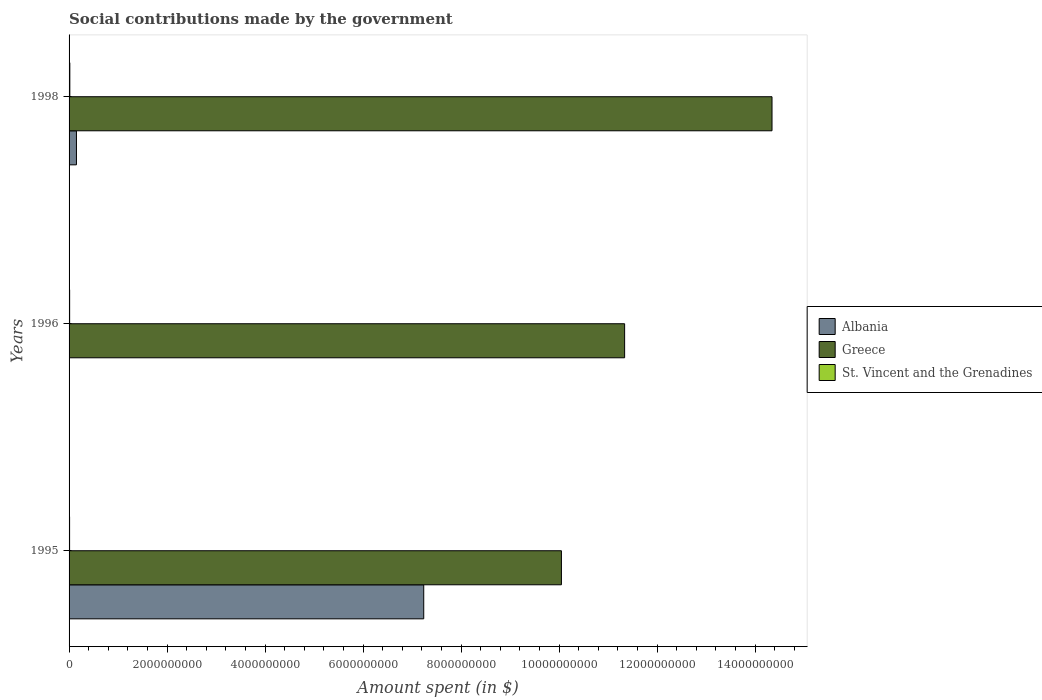How many different coloured bars are there?
Keep it short and to the point. 3. Are the number of bars per tick equal to the number of legend labels?
Your response must be concise. Yes. What is the label of the 3rd group of bars from the top?
Make the answer very short. 1995. What is the amount spent on social contributions in St. Vincent and the Grenadines in 1996?
Provide a succinct answer. 1.16e+07. Across all years, what is the maximum amount spent on social contributions in St. Vincent and the Grenadines?
Your answer should be very brief. 1.54e+07. Across all years, what is the minimum amount spent on social contributions in St. Vincent and the Grenadines?
Provide a succinct answer. 1.07e+07. In which year was the amount spent on social contributions in Albania minimum?
Provide a short and direct response. 1996. What is the total amount spent on social contributions in St. Vincent and the Grenadines in the graph?
Your answer should be very brief. 3.77e+07. What is the difference between the amount spent on social contributions in St. Vincent and the Grenadines in 1995 and that in 1998?
Ensure brevity in your answer.  -4.70e+06. What is the difference between the amount spent on social contributions in Greece in 1996 and the amount spent on social contributions in St. Vincent and the Grenadines in 1998?
Give a very brief answer. 1.13e+1. What is the average amount spent on social contributions in St. Vincent and the Grenadines per year?
Ensure brevity in your answer.  1.26e+07. In the year 1996, what is the difference between the amount spent on social contributions in Greece and amount spent on social contributions in Albania?
Your answer should be compact. 1.13e+1. In how many years, is the amount spent on social contributions in Albania greater than 5200000000 $?
Give a very brief answer. 1. What is the ratio of the amount spent on social contributions in St. Vincent and the Grenadines in 1996 to that in 1998?
Give a very brief answer. 0.75. Is the amount spent on social contributions in Albania in 1995 less than that in 1998?
Your response must be concise. No. What is the difference between the highest and the second highest amount spent on social contributions in Greece?
Provide a short and direct response. 3.01e+09. What is the difference between the highest and the lowest amount spent on social contributions in St. Vincent and the Grenadines?
Your answer should be compact. 4.70e+06. In how many years, is the amount spent on social contributions in Greece greater than the average amount spent on social contributions in Greece taken over all years?
Your response must be concise. 1. What does the 3rd bar from the top in 1995 represents?
Keep it short and to the point. Albania. What does the 1st bar from the bottom in 1998 represents?
Offer a very short reply. Albania. Are all the bars in the graph horizontal?
Make the answer very short. Yes. How many years are there in the graph?
Offer a terse response. 3. What is the difference between two consecutive major ticks on the X-axis?
Give a very brief answer. 2.00e+09. Does the graph contain any zero values?
Provide a short and direct response. No. Does the graph contain grids?
Ensure brevity in your answer.  No. Where does the legend appear in the graph?
Offer a terse response. Center right. How many legend labels are there?
Your response must be concise. 3. How are the legend labels stacked?
Your answer should be very brief. Vertical. What is the title of the graph?
Your answer should be compact. Social contributions made by the government. What is the label or title of the X-axis?
Make the answer very short. Amount spent (in $). What is the label or title of the Y-axis?
Make the answer very short. Years. What is the Amount spent (in $) in Albania in 1995?
Your answer should be compact. 7.24e+09. What is the Amount spent (in $) in Greece in 1995?
Give a very brief answer. 1.00e+1. What is the Amount spent (in $) in St. Vincent and the Grenadines in 1995?
Keep it short and to the point. 1.07e+07. What is the Amount spent (in $) of Albania in 1996?
Make the answer very short. 2000. What is the Amount spent (in $) in Greece in 1996?
Your answer should be compact. 1.13e+1. What is the Amount spent (in $) in St. Vincent and the Grenadines in 1996?
Ensure brevity in your answer.  1.16e+07. What is the Amount spent (in $) of Albania in 1998?
Your answer should be compact. 1.51e+08. What is the Amount spent (in $) of Greece in 1998?
Offer a very short reply. 1.43e+1. What is the Amount spent (in $) in St. Vincent and the Grenadines in 1998?
Give a very brief answer. 1.54e+07. Across all years, what is the maximum Amount spent (in $) in Albania?
Ensure brevity in your answer.  7.24e+09. Across all years, what is the maximum Amount spent (in $) in Greece?
Provide a succinct answer. 1.43e+1. Across all years, what is the maximum Amount spent (in $) of St. Vincent and the Grenadines?
Your answer should be compact. 1.54e+07. Across all years, what is the minimum Amount spent (in $) in Greece?
Your answer should be compact. 1.00e+1. Across all years, what is the minimum Amount spent (in $) of St. Vincent and the Grenadines?
Make the answer very short. 1.07e+07. What is the total Amount spent (in $) of Albania in the graph?
Ensure brevity in your answer.  7.39e+09. What is the total Amount spent (in $) of Greece in the graph?
Provide a succinct answer. 3.57e+1. What is the total Amount spent (in $) in St. Vincent and the Grenadines in the graph?
Offer a terse response. 3.77e+07. What is the difference between the Amount spent (in $) of Albania in 1995 and that in 1996?
Provide a succinct answer. 7.24e+09. What is the difference between the Amount spent (in $) of Greece in 1995 and that in 1996?
Provide a succinct answer. -1.29e+09. What is the difference between the Amount spent (in $) of St. Vincent and the Grenadines in 1995 and that in 1996?
Provide a succinct answer. -9.00e+05. What is the difference between the Amount spent (in $) of Albania in 1995 and that in 1998?
Your response must be concise. 7.09e+09. What is the difference between the Amount spent (in $) of Greece in 1995 and that in 1998?
Keep it short and to the point. -4.30e+09. What is the difference between the Amount spent (in $) of St. Vincent and the Grenadines in 1995 and that in 1998?
Your response must be concise. -4.70e+06. What is the difference between the Amount spent (in $) in Albania in 1996 and that in 1998?
Your answer should be compact. -1.51e+08. What is the difference between the Amount spent (in $) in Greece in 1996 and that in 1998?
Offer a very short reply. -3.01e+09. What is the difference between the Amount spent (in $) in St. Vincent and the Grenadines in 1996 and that in 1998?
Your answer should be very brief. -3.80e+06. What is the difference between the Amount spent (in $) in Albania in 1995 and the Amount spent (in $) in Greece in 1996?
Give a very brief answer. -4.10e+09. What is the difference between the Amount spent (in $) of Albania in 1995 and the Amount spent (in $) of St. Vincent and the Grenadines in 1996?
Offer a terse response. 7.23e+09. What is the difference between the Amount spent (in $) of Greece in 1995 and the Amount spent (in $) of St. Vincent and the Grenadines in 1996?
Provide a succinct answer. 1.00e+1. What is the difference between the Amount spent (in $) of Albania in 1995 and the Amount spent (in $) of Greece in 1998?
Make the answer very short. -7.11e+09. What is the difference between the Amount spent (in $) of Albania in 1995 and the Amount spent (in $) of St. Vincent and the Grenadines in 1998?
Provide a succinct answer. 7.22e+09. What is the difference between the Amount spent (in $) in Greece in 1995 and the Amount spent (in $) in St. Vincent and the Grenadines in 1998?
Offer a terse response. 1.00e+1. What is the difference between the Amount spent (in $) of Albania in 1996 and the Amount spent (in $) of Greece in 1998?
Offer a terse response. -1.43e+1. What is the difference between the Amount spent (in $) in Albania in 1996 and the Amount spent (in $) in St. Vincent and the Grenadines in 1998?
Give a very brief answer. -1.54e+07. What is the difference between the Amount spent (in $) in Greece in 1996 and the Amount spent (in $) in St. Vincent and the Grenadines in 1998?
Keep it short and to the point. 1.13e+1. What is the average Amount spent (in $) in Albania per year?
Make the answer very short. 2.46e+09. What is the average Amount spent (in $) in Greece per year?
Your response must be concise. 1.19e+1. What is the average Amount spent (in $) of St. Vincent and the Grenadines per year?
Keep it short and to the point. 1.26e+07. In the year 1995, what is the difference between the Amount spent (in $) in Albania and Amount spent (in $) in Greece?
Provide a succinct answer. -2.81e+09. In the year 1995, what is the difference between the Amount spent (in $) of Albania and Amount spent (in $) of St. Vincent and the Grenadines?
Ensure brevity in your answer.  7.23e+09. In the year 1995, what is the difference between the Amount spent (in $) of Greece and Amount spent (in $) of St. Vincent and the Grenadines?
Your answer should be compact. 1.00e+1. In the year 1996, what is the difference between the Amount spent (in $) of Albania and Amount spent (in $) of Greece?
Offer a very short reply. -1.13e+1. In the year 1996, what is the difference between the Amount spent (in $) in Albania and Amount spent (in $) in St. Vincent and the Grenadines?
Offer a terse response. -1.16e+07. In the year 1996, what is the difference between the Amount spent (in $) in Greece and Amount spent (in $) in St. Vincent and the Grenadines?
Your answer should be very brief. 1.13e+1. In the year 1998, what is the difference between the Amount spent (in $) in Albania and Amount spent (in $) in Greece?
Offer a very short reply. -1.42e+1. In the year 1998, what is the difference between the Amount spent (in $) of Albania and Amount spent (in $) of St. Vincent and the Grenadines?
Keep it short and to the point. 1.35e+08. In the year 1998, what is the difference between the Amount spent (in $) of Greece and Amount spent (in $) of St. Vincent and the Grenadines?
Offer a terse response. 1.43e+1. What is the ratio of the Amount spent (in $) in Albania in 1995 to that in 1996?
Keep it short and to the point. 3.62e+06. What is the ratio of the Amount spent (in $) of Greece in 1995 to that in 1996?
Keep it short and to the point. 0.89. What is the ratio of the Amount spent (in $) in St. Vincent and the Grenadines in 1995 to that in 1996?
Keep it short and to the point. 0.92. What is the ratio of the Amount spent (in $) of Albania in 1995 to that in 1998?
Offer a very short reply. 48.03. What is the ratio of the Amount spent (in $) in Greece in 1995 to that in 1998?
Ensure brevity in your answer.  0.7. What is the ratio of the Amount spent (in $) in St. Vincent and the Grenadines in 1995 to that in 1998?
Your answer should be very brief. 0.69. What is the ratio of the Amount spent (in $) of Albania in 1996 to that in 1998?
Your response must be concise. 0. What is the ratio of the Amount spent (in $) in Greece in 1996 to that in 1998?
Your response must be concise. 0.79. What is the ratio of the Amount spent (in $) of St. Vincent and the Grenadines in 1996 to that in 1998?
Provide a short and direct response. 0.75. What is the difference between the highest and the second highest Amount spent (in $) in Albania?
Keep it short and to the point. 7.09e+09. What is the difference between the highest and the second highest Amount spent (in $) of Greece?
Ensure brevity in your answer.  3.01e+09. What is the difference between the highest and the second highest Amount spent (in $) in St. Vincent and the Grenadines?
Offer a terse response. 3.80e+06. What is the difference between the highest and the lowest Amount spent (in $) in Albania?
Your response must be concise. 7.24e+09. What is the difference between the highest and the lowest Amount spent (in $) in Greece?
Make the answer very short. 4.30e+09. What is the difference between the highest and the lowest Amount spent (in $) in St. Vincent and the Grenadines?
Provide a succinct answer. 4.70e+06. 